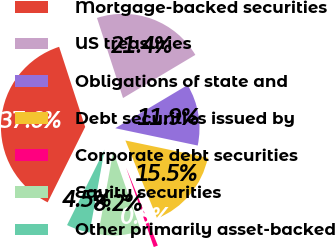Convert chart to OTSL. <chart><loc_0><loc_0><loc_500><loc_500><pie_chart><fcel>Mortgage-backed securities<fcel>US treasuries<fcel>Obligations of state and<fcel>Debt securities issued by<fcel>Corporate debt securities<fcel>Equity securities<fcel>Other primarily asset-backed<nl><fcel>37.65%<fcel>21.44%<fcel>11.86%<fcel>15.55%<fcel>0.82%<fcel>8.18%<fcel>4.5%<nl></chart> 